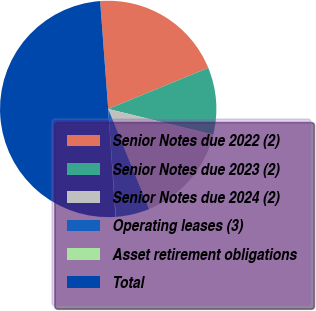<chart> <loc_0><loc_0><loc_500><loc_500><pie_chart><fcel>Senior Notes due 2022 (2)<fcel>Senior Notes due 2023 (2)<fcel>Senior Notes due 2024 (2)<fcel>Operating leases (3)<fcel>Asset retirement obligations<fcel>Total<nl><fcel>19.99%<fcel>10.02%<fcel>15.01%<fcel>5.04%<fcel>0.06%<fcel>49.88%<nl></chart> 